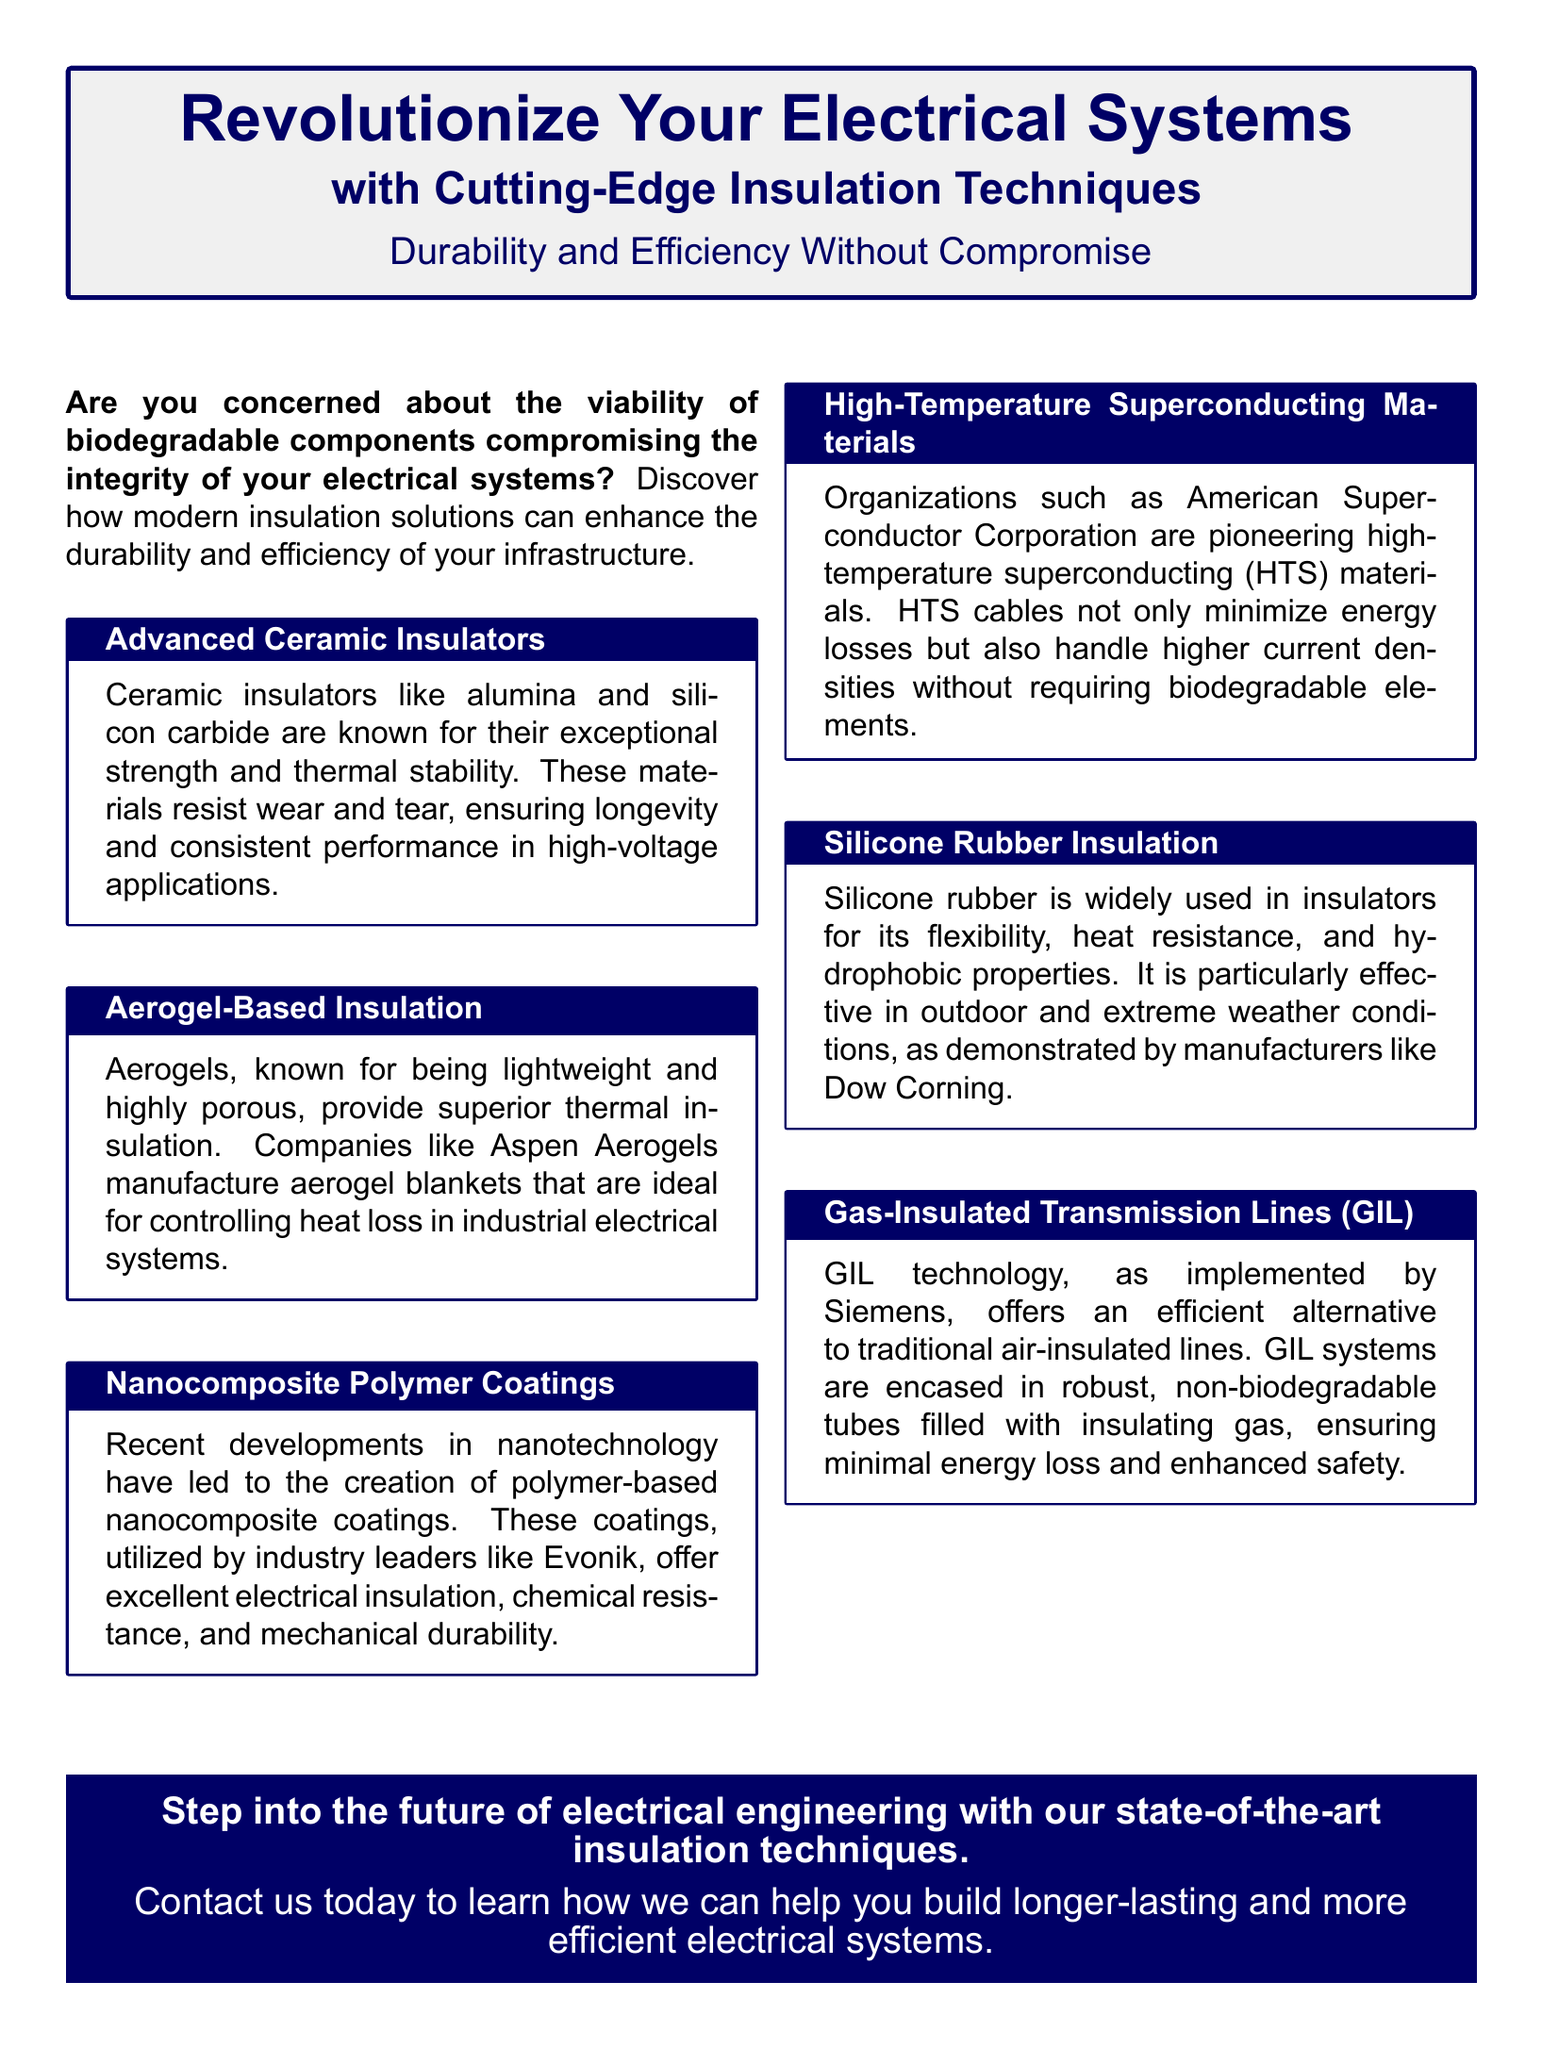What are advanced ceramic insulators known for? Advanced ceramic insulators are known for their exceptional strength and thermal stability.
Answer: Exceptional strength and thermal stability Which company manufactures aerogel blankets? Aspen Aerogels is mentioned as the manufacturer of aerogel blankets.
Answer: Aspen Aerogels What type of materials are high-temperature superconducting cables? High-temperature superconducting cables minimize energy losses and handle higher current densities.
Answer: High-temperature superconducting materials What is the benefit of silicone rubber insulation? Silicone rubber insulation is particularly effective in outdoor and extreme weather conditions.
Answer: Effectiveness in outdoor and extreme weather conditions What do Gas-Insulated Transmission Lines (GIL) minimize? GIL technology ensures minimal energy loss in electrical systems.
Answer: Minimal energy loss Which advanced insulation technique is lightweight and highly porous? Aerogel-based insulation is known for being lightweight and highly porous.
Answer: Aerogel-based insulation What is a key feature of nanocomposite polymer coatings? Nanocomposite polymer coatings offer excellent electrical insulation.
Answer: Excellent electrical insulation What is the primary focus of this advertisement? The primary focus is on enhancing the durability and efficiency of electrical systems.
Answer: Enhancing durability and efficiency of electrical systems 